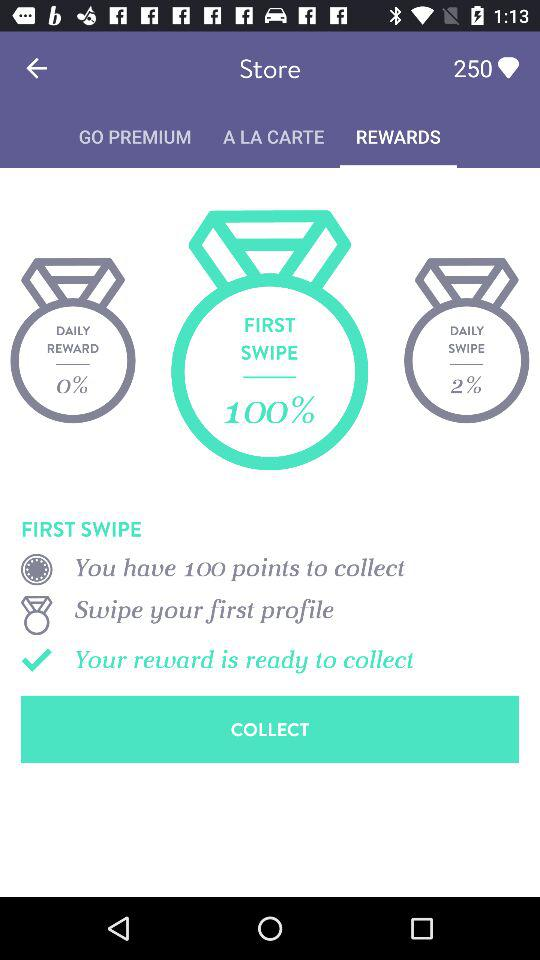What is the age of Michele? Michele is 24 years old. 